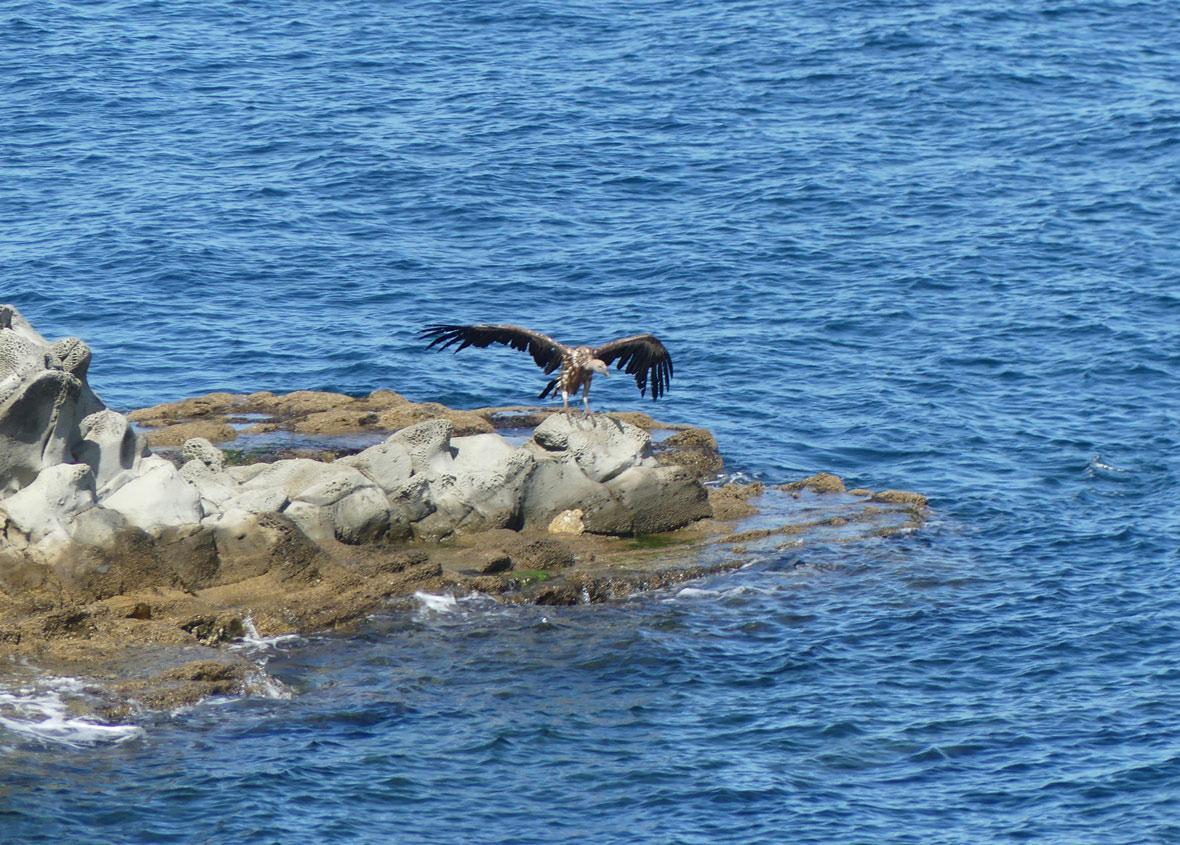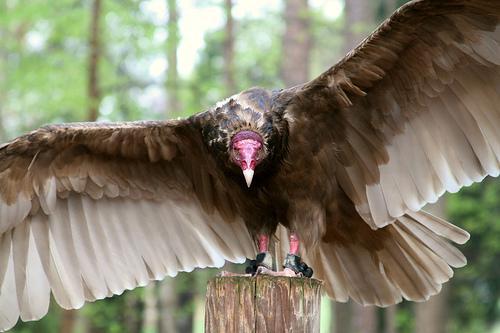The first image is the image on the left, the second image is the image on the right. Considering the images on both sides, is "An image shows one leftward swimming bird with wings that are not spread." valid? Answer yes or no. No. The first image is the image on the left, the second image is the image on the right. Given the left and right images, does the statement "There are two birds, both in water." hold true? Answer yes or no. No. 